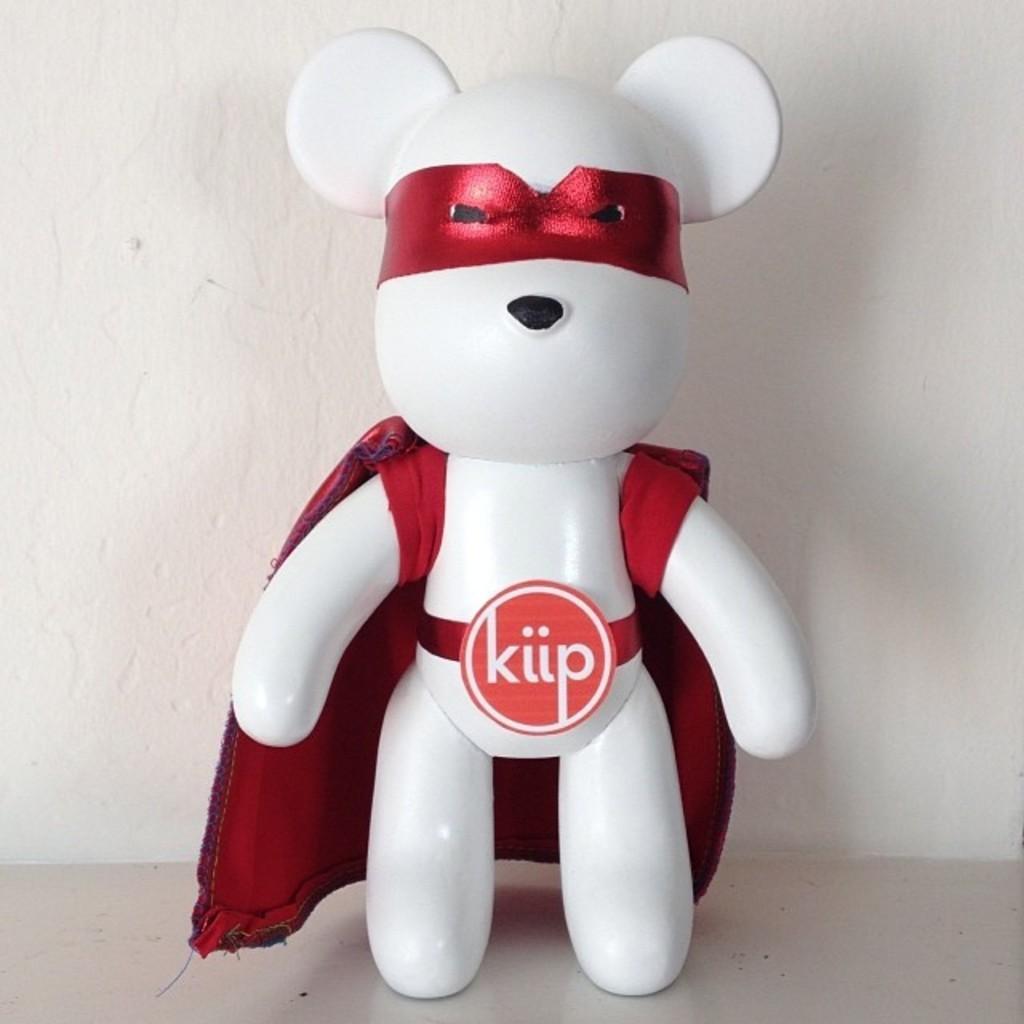Could you give a brief overview of what you see in this image? In this image I can see a toy on the floor and a wall. This image is taken, may be in a room. 